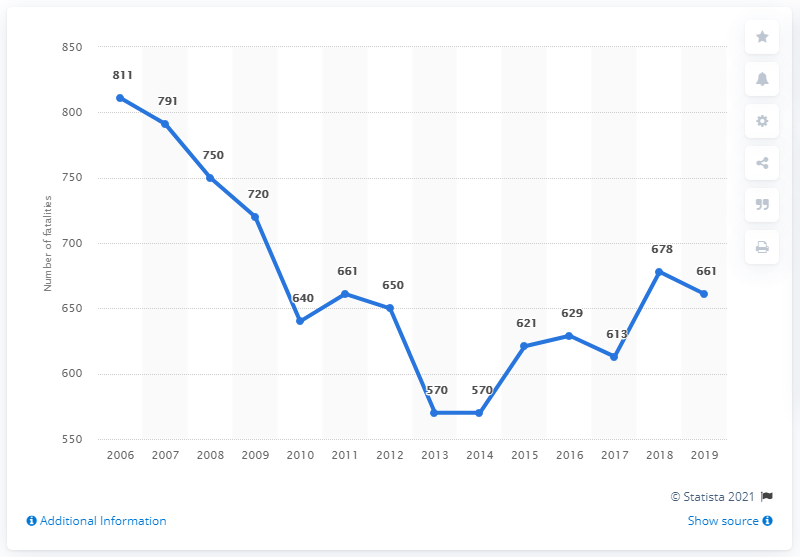List a handful of essential elements in this visual. The chart shows the values of a certain metric over time, with the lowest value being 570. In 2019, a total of 661 people lost their lives on the roads in the Netherlands. The average of the last three years is approximately 650.66. 